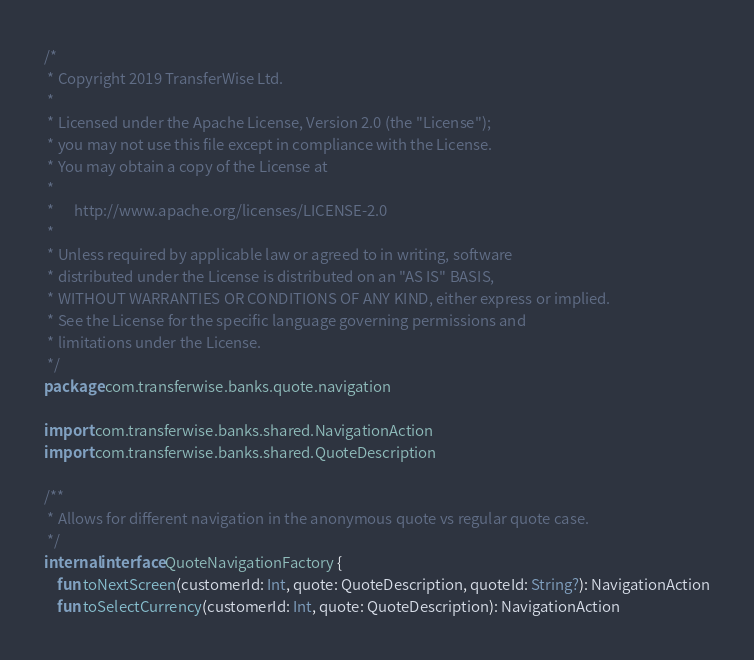<code> <loc_0><loc_0><loc_500><loc_500><_Kotlin_>/*
 * Copyright 2019 TransferWise Ltd.
 *
 * Licensed under the Apache License, Version 2.0 (the "License");
 * you may not use this file except in compliance with the License.
 * You may obtain a copy of the License at
 *
 *      http://www.apache.org/licenses/LICENSE-2.0
 *
 * Unless required by applicable law or agreed to in writing, software
 * distributed under the License is distributed on an "AS IS" BASIS,
 * WITHOUT WARRANTIES OR CONDITIONS OF ANY KIND, either express or implied.
 * See the License for the specific language governing permissions and
 * limitations under the License.
 */
package com.transferwise.banks.quote.navigation

import com.transferwise.banks.shared.NavigationAction
import com.transferwise.banks.shared.QuoteDescription

/**
 * Allows for different navigation in the anonymous quote vs regular quote case.
 */
internal interface QuoteNavigationFactory {
    fun toNextScreen(customerId: Int, quote: QuoteDescription, quoteId: String?): NavigationAction
    fun toSelectCurrency(customerId: Int, quote: QuoteDescription): NavigationAction</code> 